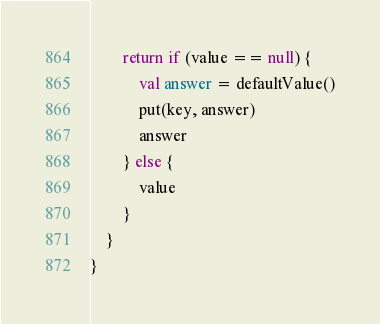Convert code to text. <code><loc_0><loc_0><loc_500><loc_500><_Kotlin_>        return if (value == null) {
            val answer = defaultValue()
            put(key, answer)
            answer
        } else {
            value
        }
    }
}
</code> 